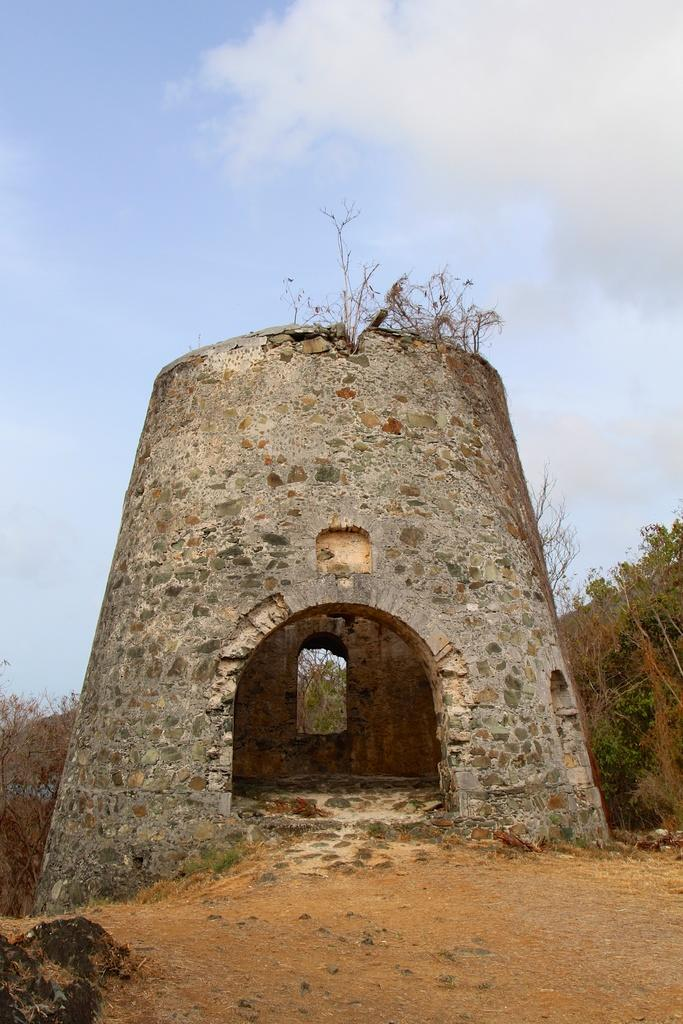What structure can be seen in the picture? There is a small tower in the picture. What type of vegetation is present in the picture? There are trees in the picture. How would you describe the sky in the picture? The sky is blue and cloudy in the picture. What type of pot is being smashed by the cub in the picture? There is no pot or cub present in the picture; it only features a small tower, trees, and a blue and cloudy sky. 